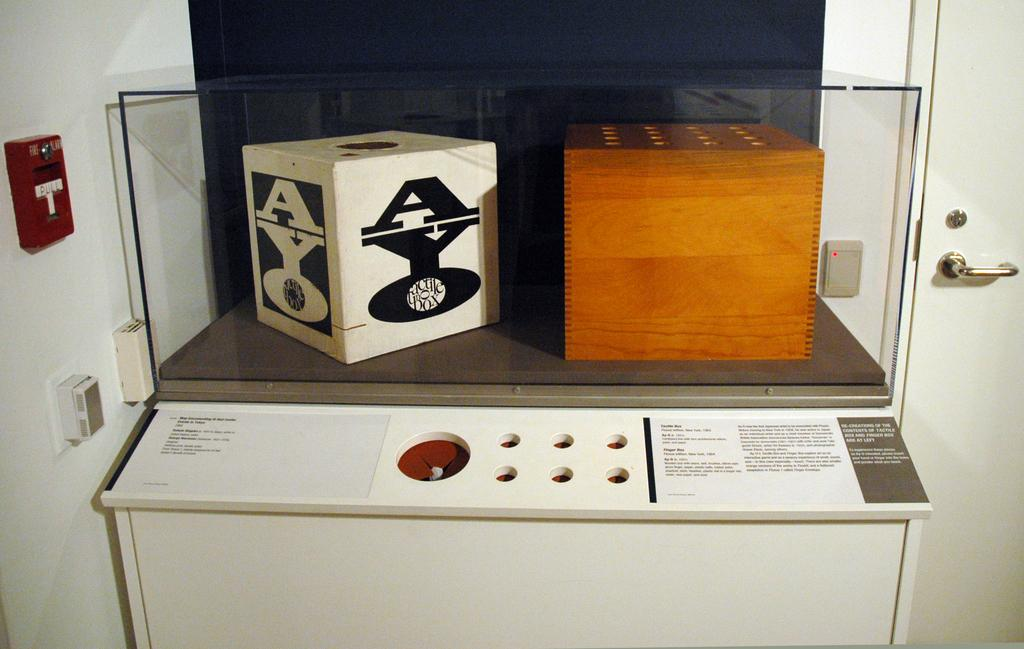<image>
Write a terse but informative summary of the picture. A black and white box has the word AYO on it. 